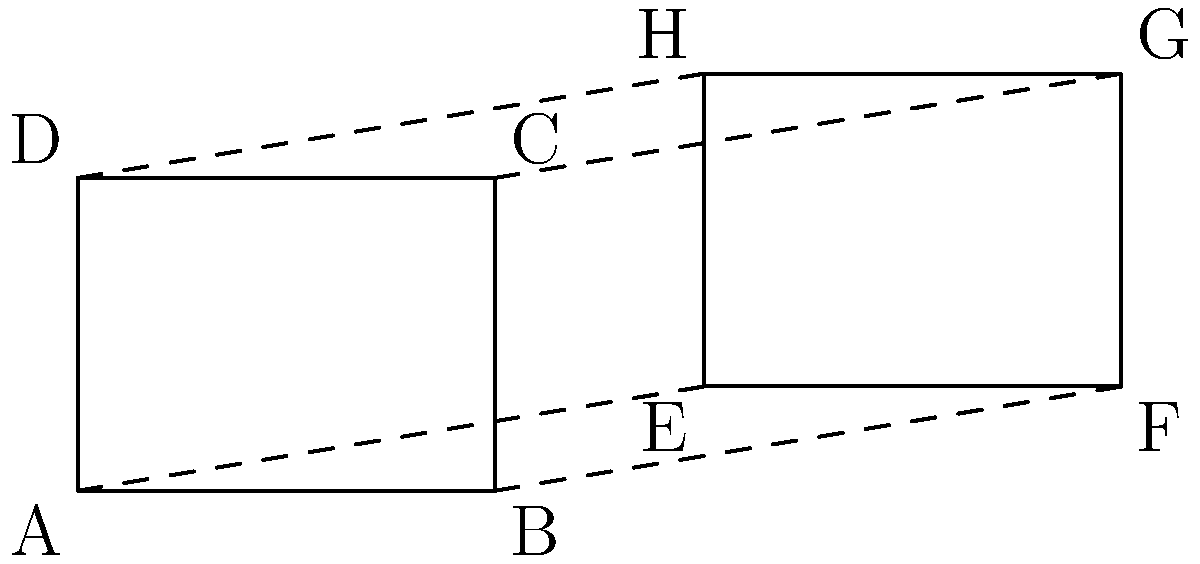In a military vehicle schematic, two rectangular panels ABCD and EFGH are shown. Given that AB = 4 units, BC = 3 units, and EF = 4 units, determine if these panels are congruent. If so, identify the congruence transformation that maps ABCD onto EFGH. To determine if the rectangular panels ABCD and EFGH are congruent, we need to follow these steps:

1. Check if the corresponding sides are equal:
   AB = 4 units and EF = 4 units (given)
   BC = 3 units (given)
   
2. For rectangles to be congruent, both pairs of sides must be equal. We need to verify if FG = BC:
   Since EFGH is also a rectangle, and EF = AB, it follows that FG must equal BC (3 units).

3. Therefore, ABCD and EFGH have equal corresponding sides:
   AB = EF = 4 units
   BC = FG = 3 units
   
4. In rectangles, all angles are 90°, so the corresponding angles are also equal.

5. By the definition of congruence (SSS - Side-Side-Side), if all corresponding sides and angles of two shapes are equal, the shapes are congruent.

6. To identify the congruence transformation:
   - The rectangles are not in the same position, so it's not a direct congruence.
   - EFGH is shifted up and to the right compared to ABCD.
   - This transformation is a translation.

7. The translation vector can be determined by connecting any corresponding points:
   Vector $\vec{AE} = (6-0, 1-0) = (6, 1)$

Therefore, the panels are congruent, and the congruence transformation is a translation by the vector (6, 1).
Answer: Yes; translation by vector (6, 1) 